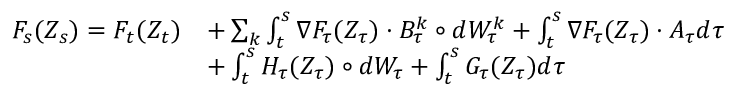<formula> <loc_0><loc_0><loc_500><loc_500>\begin{array} { r l } { F _ { s } ( Z _ { s } ) = F _ { t } ( Z _ { t } ) } & { + \sum _ { k } \int _ { t } ^ { s } \nabla F _ { \tau } ( Z _ { \tau } ) \cdot B _ { \tau } ^ { k } \circ d W _ { \tau } ^ { k } + \int _ { t } ^ { s } \nabla F _ { \tau } ( Z _ { \tau } ) \cdot A _ { \tau } d \tau } \\ & { + \int _ { t } ^ { s } H _ { \tau } ( Z _ { \tau } ) \circ d W _ { \tau } + \int _ { t } ^ { s } G _ { \tau } ( Z _ { \tau } ) d \tau } \end{array}</formula> 